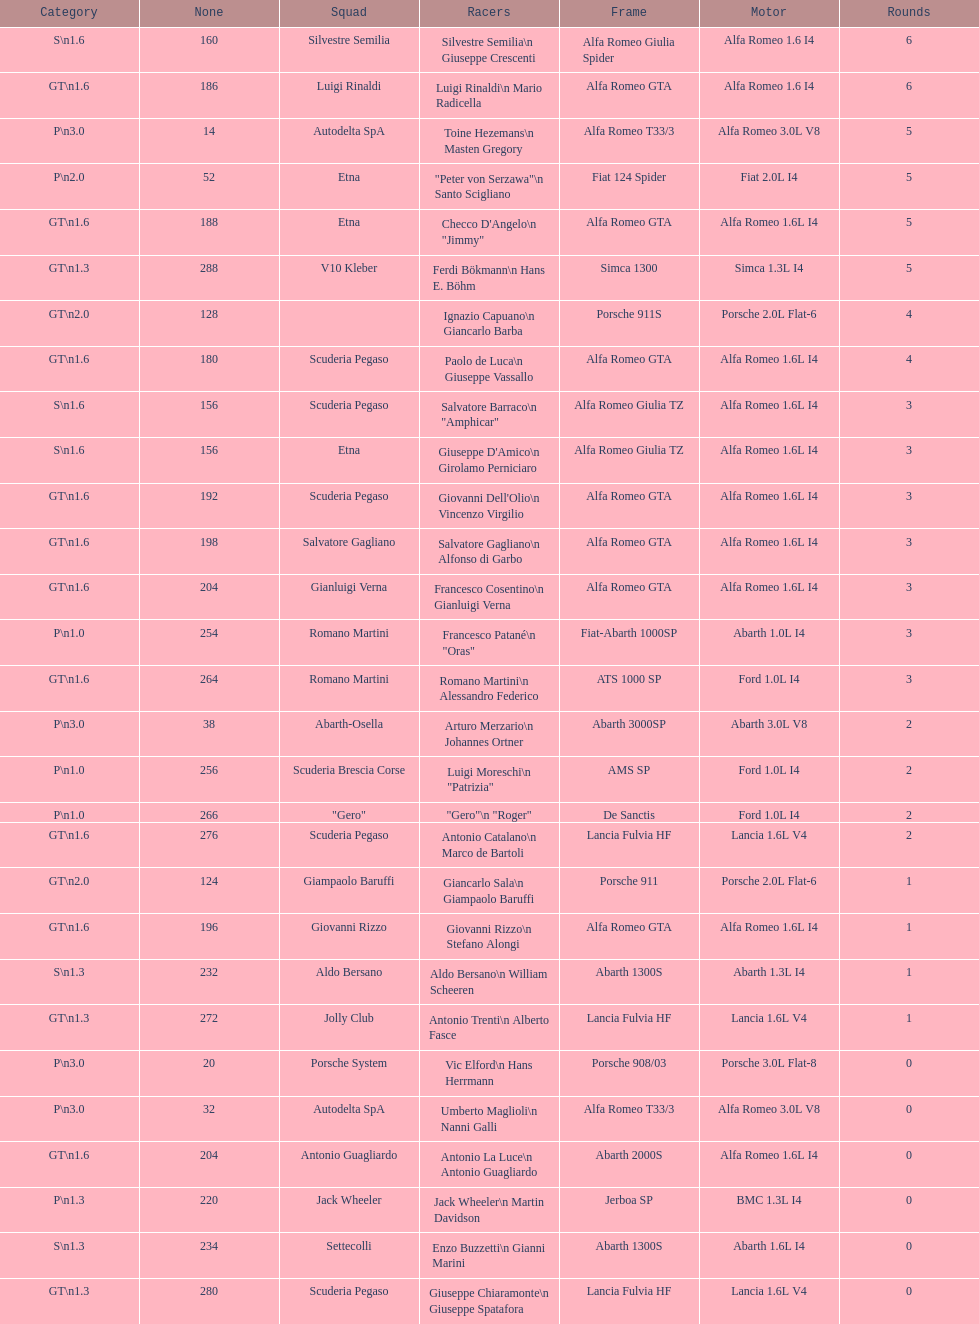How many laps does v10 kleber have? 5. Write the full table. {'header': ['Category', 'None', 'Squad', 'Racers', 'Frame', 'Motor', 'Rounds'], 'rows': [['S\\n1.6', '160', 'Silvestre Semilia', 'Silvestre Semilia\\n Giuseppe Crescenti', 'Alfa Romeo Giulia Spider', 'Alfa Romeo 1.6 I4', '6'], ['GT\\n1.6', '186', 'Luigi Rinaldi', 'Luigi Rinaldi\\n Mario Radicella', 'Alfa Romeo GTA', 'Alfa Romeo 1.6 I4', '6'], ['P\\n3.0', '14', 'Autodelta SpA', 'Toine Hezemans\\n Masten Gregory', 'Alfa Romeo T33/3', 'Alfa Romeo 3.0L V8', '5'], ['P\\n2.0', '52', 'Etna', '"Peter von Serzawa"\\n Santo Scigliano', 'Fiat 124 Spider', 'Fiat 2.0L I4', '5'], ['GT\\n1.6', '188', 'Etna', 'Checco D\'Angelo\\n "Jimmy"', 'Alfa Romeo GTA', 'Alfa Romeo 1.6L I4', '5'], ['GT\\n1.3', '288', 'V10 Kleber', 'Ferdi Bökmann\\n Hans E. Böhm', 'Simca 1300', 'Simca 1.3L I4', '5'], ['GT\\n2.0', '128', '', 'Ignazio Capuano\\n Giancarlo Barba', 'Porsche 911S', 'Porsche 2.0L Flat-6', '4'], ['GT\\n1.6', '180', 'Scuderia Pegaso', 'Paolo de Luca\\n Giuseppe Vassallo', 'Alfa Romeo GTA', 'Alfa Romeo 1.6L I4', '4'], ['S\\n1.6', '156', 'Scuderia Pegaso', 'Salvatore Barraco\\n "Amphicar"', 'Alfa Romeo Giulia TZ', 'Alfa Romeo 1.6L I4', '3'], ['S\\n1.6', '156', 'Etna', "Giuseppe D'Amico\\n Girolamo Perniciaro", 'Alfa Romeo Giulia TZ', 'Alfa Romeo 1.6L I4', '3'], ['GT\\n1.6', '192', 'Scuderia Pegaso', "Giovanni Dell'Olio\\n Vincenzo Virgilio", 'Alfa Romeo GTA', 'Alfa Romeo 1.6L I4', '3'], ['GT\\n1.6', '198', 'Salvatore Gagliano', 'Salvatore Gagliano\\n Alfonso di Garbo', 'Alfa Romeo GTA', 'Alfa Romeo 1.6L I4', '3'], ['GT\\n1.6', '204', 'Gianluigi Verna', 'Francesco Cosentino\\n Gianluigi Verna', 'Alfa Romeo GTA', 'Alfa Romeo 1.6L I4', '3'], ['P\\n1.0', '254', 'Romano Martini', 'Francesco Patané\\n "Oras"', 'Fiat-Abarth 1000SP', 'Abarth 1.0L I4', '3'], ['GT\\n1.6', '264', 'Romano Martini', 'Romano Martini\\n Alessandro Federico', 'ATS 1000 SP', 'Ford 1.0L I4', '3'], ['P\\n3.0', '38', 'Abarth-Osella', 'Arturo Merzario\\n Johannes Ortner', 'Abarth 3000SP', 'Abarth 3.0L V8', '2'], ['P\\n1.0', '256', 'Scuderia Brescia Corse', 'Luigi Moreschi\\n "Patrizia"', 'AMS SP', 'Ford 1.0L I4', '2'], ['P\\n1.0', '266', '"Gero"', '"Gero"\\n "Roger"', 'De Sanctis', 'Ford 1.0L I4', '2'], ['GT\\n1.6', '276', 'Scuderia Pegaso', 'Antonio Catalano\\n Marco de Bartoli', 'Lancia Fulvia HF', 'Lancia 1.6L V4', '2'], ['GT\\n2.0', '124', 'Giampaolo Baruffi', 'Giancarlo Sala\\n Giampaolo Baruffi', 'Porsche 911', 'Porsche 2.0L Flat-6', '1'], ['GT\\n1.6', '196', 'Giovanni Rizzo', 'Giovanni Rizzo\\n Stefano Alongi', 'Alfa Romeo GTA', 'Alfa Romeo 1.6L I4', '1'], ['S\\n1.3', '232', 'Aldo Bersano', 'Aldo Bersano\\n William Scheeren', 'Abarth 1300S', 'Abarth 1.3L I4', '1'], ['GT\\n1.3', '272', 'Jolly Club', 'Antonio Trenti\\n Alberto Fasce', 'Lancia Fulvia HF', 'Lancia 1.6L V4', '1'], ['P\\n3.0', '20', 'Porsche System', 'Vic Elford\\n Hans Herrmann', 'Porsche 908/03', 'Porsche 3.0L Flat-8', '0'], ['P\\n3.0', '32', 'Autodelta SpA', 'Umberto Maglioli\\n Nanni Galli', 'Alfa Romeo T33/3', 'Alfa Romeo 3.0L V8', '0'], ['GT\\n1.6', '204', 'Antonio Guagliardo', 'Antonio La Luce\\n Antonio Guagliardo', 'Abarth 2000S', 'Alfa Romeo 1.6L I4', '0'], ['P\\n1.3', '220', 'Jack Wheeler', 'Jack Wheeler\\n Martin Davidson', 'Jerboa SP', 'BMC 1.3L I4', '0'], ['S\\n1.3', '234', 'Settecolli', 'Enzo Buzzetti\\n Gianni Marini', 'Abarth 1300S', 'Abarth 1.6L I4', '0'], ['GT\\n1.3', '280', 'Scuderia Pegaso', 'Giuseppe Chiaramonte\\n Giuseppe Spatafora', 'Lancia Fulvia HF', 'Lancia 1.6L V4', '0']]} 